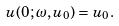Convert formula to latex. <formula><loc_0><loc_0><loc_500><loc_500>u ( 0 ; \omega , u _ { 0 } ) = u _ { 0 } .</formula> 